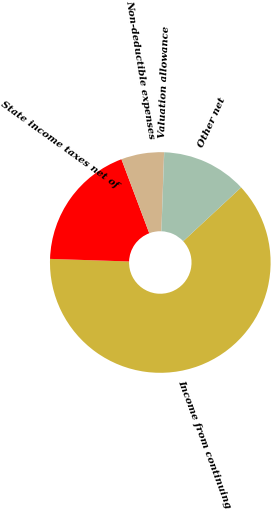Convert chart. <chart><loc_0><loc_0><loc_500><loc_500><pie_chart><fcel>Income from continuing<fcel>State income taxes net of<fcel>Non-deductible expenses<fcel>Valuation allowance<fcel>Other net<nl><fcel>62.43%<fcel>18.75%<fcel>6.27%<fcel>0.03%<fcel>12.51%<nl></chart> 